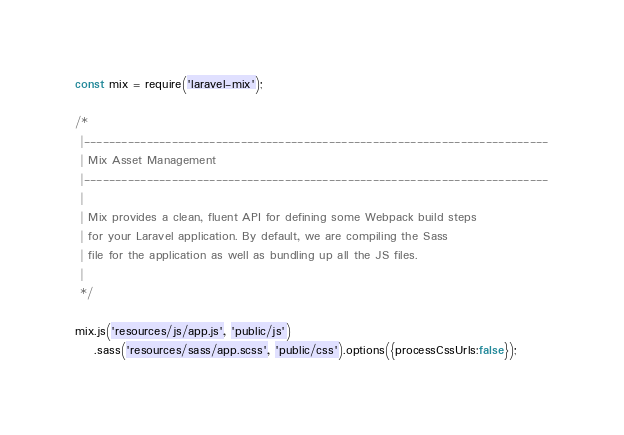<code> <loc_0><loc_0><loc_500><loc_500><_JavaScript_>const mix = require('laravel-mix');

/*
 |--------------------------------------------------------------------------
 | Mix Asset Management
 |--------------------------------------------------------------------------
 |
 | Mix provides a clean, fluent API for defining some Webpack build steps
 | for your Laravel application. By default, we are compiling the Sass
 | file for the application as well as bundling up all the JS files.
 |
 */

mix.js('resources/js/app.js', 'public/js')
    .sass('resources/sass/app.scss', 'public/css').options({processCssUrls:false});
</code> 